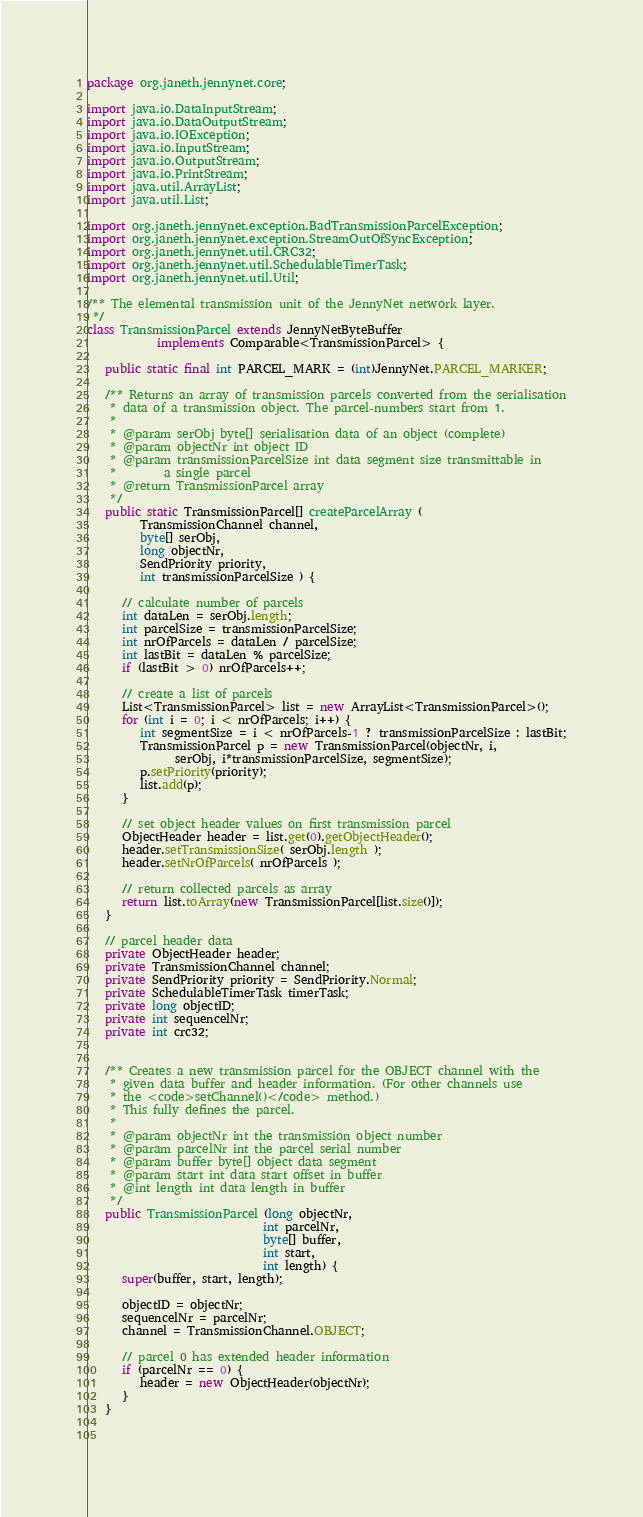Convert code to text. <code><loc_0><loc_0><loc_500><loc_500><_Java_>package org.janeth.jennynet.core;

import java.io.DataInputStream;
import java.io.DataOutputStream;
import java.io.IOException;
import java.io.InputStream;
import java.io.OutputStream;
import java.io.PrintStream;
import java.util.ArrayList;
import java.util.List;

import org.janeth.jennynet.exception.BadTransmissionParcelException;
import org.janeth.jennynet.exception.StreamOutOfSyncException;
import org.janeth.jennynet.util.CRC32;
import org.janeth.jennynet.util.SchedulableTimerTask;
import org.janeth.jennynet.util.Util;

/** The elemental transmission unit of the JennyNet network layer.
 */
class TransmissionParcel extends JennyNetByteBuffer 
			implements Comparable<TransmissionParcel> {
   
   public static final int PARCEL_MARK = (int)JennyNet.PARCEL_MARKER;
   
   /** Returns an array of transmission parcels converted from the serialisation
    * data of a transmission object. The parcel-numbers start from 1.
    *  
    * @param serObj byte[] serialisation data of an object (complete)
    * @param objectNr int object ID
    * @param transmissionParcelSize int data segment size transmittable in 
    *        a single parcel
    * @return TransmissionParcel array 
    */
   public static TransmissionParcel[] createParcelArray (
         TransmissionChannel channel, 
         byte[] serObj, 
         long objectNr, 
         SendPriority priority,
         int transmissionParcelSize ) {

      // calculate number of parcels
      int dataLen = serObj.length;
      int parcelSize = transmissionParcelSize;
      int nrOfParcels = dataLen / parcelSize;
      int lastBit = dataLen % parcelSize; 
      if (lastBit > 0) nrOfParcels++;
      
      // create a list of parcels
      List<TransmissionParcel> list = new ArrayList<TransmissionParcel>();
      for (int i = 0; i < nrOfParcels; i++) {
         int segmentSize = i < nrOfParcels-1 ? transmissionParcelSize : lastBit;
         TransmissionParcel p = new TransmissionParcel(objectNr, i, 
               serObj, i*transmissionParcelSize, segmentSize);
         p.setPriority(priority);
         list.add(p);
      }

      // set object header values on first transmission parcel
      ObjectHeader header = list.get(0).getObjectHeader();
      header.setTransmissionSize( serObj.length );
      header.setNrOfParcels( nrOfParcels );
      
      // return collected parcels as array
      return list.toArray(new TransmissionParcel[list.size()]);
   }

   // parcel header data
   private ObjectHeader header;
   private TransmissionChannel channel;
   private SendPriority priority = SendPriority.Normal;
   private SchedulableTimerTask timerTask;
   private long objectID;
   private int sequencelNr;
   private int crc32;
   
   
   /** Creates a new transmission parcel for the OBJECT channel with the 
    * given data buffer and header information. (For other channels use
    * the <code>setChannel()</code> method.)  
    * This fully defines the parcel.
    * 
    * @param objectNr int the transmission object number
    * @param parcelNr int the parcel serial number
    * @param buffer byte[] object data segment
    * @param start int data start offset in buffer
    * @int length int data length in buffer
    */
   public TransmissionParcel (long objectNr, 
		   					  int parcelNr, 
		   					  byte[] buffer, 
		   					  int start, 
		   					  int length) {
      super(buffer, start, length);

      objectID = objectNr;
      sequencelNr = parcelNr;
      channel = TransmissionChannel.OBJECT;
      
      // parcel 0 has extended header information
      if (parcelNr == 0) {
         header = new ObjectHeader(objectNr);
      }
   }

   </code> 